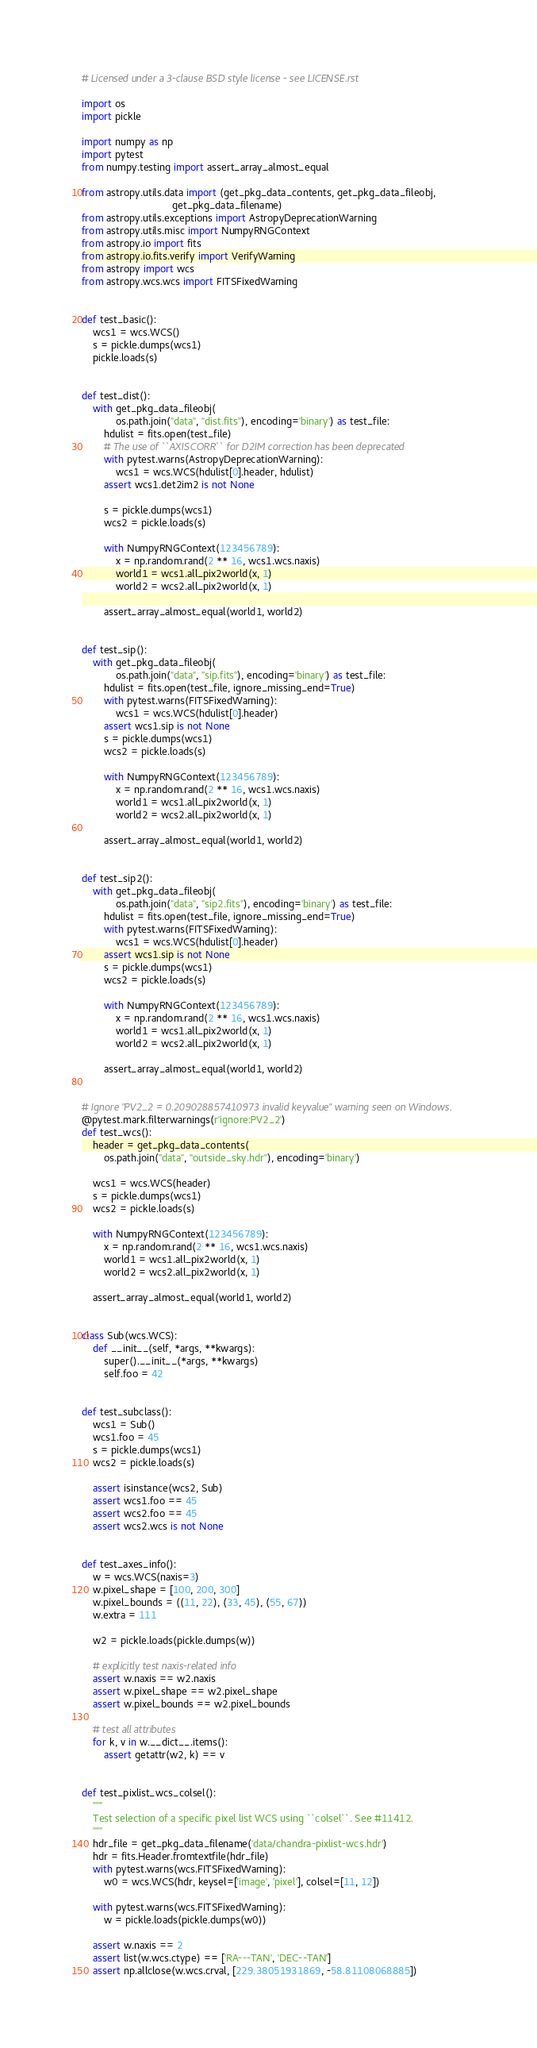Convert code to text. <code><loc_0><loc_0><loc_500><loc_500><_Python_># Licensed under a 3-clause BSD style license - see LICENSE.rst

import os
import pickle

import numpy as np
import pytest
from numpy.testing import assert_array_almost_equal

from astropy.utils.data import (get_pkg_data_contents, get_pkg_data_fileobj,
                                get_pkg_data_filename)
from astropy.utils.exceptions import AstropyDeprecationWarning
from astropy.utils.misc import NumpyRNGContext
from astropy.io import fits
from astropy.io.fits.verify import VerifyWarning
from astropy import wcs
from astropy.wcs.wcs import FITSFixedWarning


def test_basic():
    wcs1 = wcs.WCS()
    s = pickle.dumps(wcs1)
    pickle.loads(s)


def test_dist():
    with get_pkg_data_fileobj(
            os.path.join("data", "dist.fits"), encoding='binary') as test_file:
        hdulist = fits.open(test_file)
        # The use of ``AXISCORR`` for D2IM correction has been deprecated
        with pytest.warns(AstropyDeprecationWarning):
            wcs1 = wcs.WCS(hdulist[0].header, hdulist)
        assert wcs1.det2im2 is not None

        s = pickle.dumps(wcs1)
        wcs2 = pickle.loads(s)

        with NumpyRNGContext(123456789):
            x = np.random.rand(2 ** 16, wcs1.wcs.naxis)
            world1 = wcs1.all_pix2world(x, 1)
            world2 = wcs2.all_pix2world(x, 1)

        assert_array_almost_equal(world1, world2)


def test_sip():
    with get_pkg_data_fileobj(
            os.path.join("data", "sip.fits"), encoding='binary') as test_file:
        hdulist = fits.open(test_file, ignore_missing_end=True)
        with pytest.warns(FITSFixedWarning):
            wcs1 = wcs.WCS(hdulist[0].header)
        assert wcs1.sip is not None
        s = pickle.dumps(wcs1)
        wcs2 = pickle.loads(s)

        with NumpyRNGContext(123456789):
            x = np.random.rand(2 ** 16, wcs1.wcs.naxis)
            world1 = wcs1.all_pix2world(x, 1)
            world2 = wcs2.all_pix2world(x, 1)

        assert_array_almost_equal(world1, world2)


def test_sip2():
    with get_pkg_data_fileobj(
            os.path.join("data", "sip2.fits"), encoding='binary') as test_file:
        hdulist = fits.open(test_file, ignore_missing_end=True)
        with pytest.warns(FITSFixedWarning):
            wcs1 = wcs.WCS(hdulist[0].header)
        assert wcs1.sip is not None
        s = pickle.dumps(wcs1)
        wcs2 = pickle.loads(s)

        with NumpyRNGContext(123456789):
            x = np.random.rand(2 ** 16, wcs1.wcs.naxis)
            world1 = wcs1.all_pix2world(x, 1)
            world2 = wcs2.all_pix2world(x, 1)

        assert_array_almost_equal(world1, world2)


# Ignore "PV2_2 = 0.209028857410973 invalid keyvalue" warning seen on Windows.
@pytest.mark.filterwarnings(r'ignore:PV2_2')
def test_wcs():
    header = get_pkg_data_contents(
        os.path.join("data", "outside_sky.hdr"), encoding='binary')

    wcs1 = wcs.WCS(header)
    s = pickle.dumps(wcs1)
    wcs2 = pickle.loads(s)

    with NumpyRNGContext(123456789):
        x = np.random.rand(2 ** 16, wcs1.wcs.naxis)
        world1 = wcs1.all_pix2world(x, 1)
        world2 = wcs2.all_pix2world(x, 1)

    assert_array_almost_equal(world1, world2)


class Sub(wcs.WCS):
    def __init__(self, *args, **kwargs):
        super().__init__(*args, **kwargs)
        self.foo = 42


def test_subclass():
    wcs1 = Sub()
    wcs1.foo = 45
    s = pickle.dumps(wcs1)
    wcs2 = pickle.loads(s)

    assert isinstance(wcs2, Sub)
    assert wcs1.foo == 45
    assert wcs2.foo == 45
    assert wcs2.wcs is not None


def test_axes_info():
    w = wcs.WCS(naxis=3)
    w.pixel_shape = [100, 200, 300]
    w.pixel_bounds = ((11, 22), (33, 45), (55, 67))
    w.extra = 111

    w2 = pickle.loads(pickle.dumps(w))

    # explicitly test naxis-related info
    assert w.naxis == w2.naxis
    assert w.pixel_shape == w2.pixel_shape
    assert w.pixel_bounds == w2.pixel_bounds

    # test all attributes
    for k, v in w.__dict__.items():
        assert getattr(w2, k) == v


def test_pixlist_wcs_colsel():
    """
    Test selection of a specific pixel list WCS using ``colsel``. See #11412.
    """
    hdr_file = get_pkg_data_filename('data/chandra-pixlist-wcs.hdr')
    hdr = fits.Header.fromtextfile(hdr_file)
    with pytest.warns(wcs.FITSFixedWarning):
        w0 = wcs.WCS(hdr, keysel=['image', 'pixel'], colsel=[11, 12])

    with pytest.warns(wcs.FITSFixedWarning):
        w = pickle.loads(pickle.dumps(w0))

    assert w.naxis == 2
    assert list(w.wcs.ctype) == ['RA---TAN', 'DEC--TAN']
    assert np.allclose(w.wcs.crval, [229.38051931869, -58.81108068885])</code> 